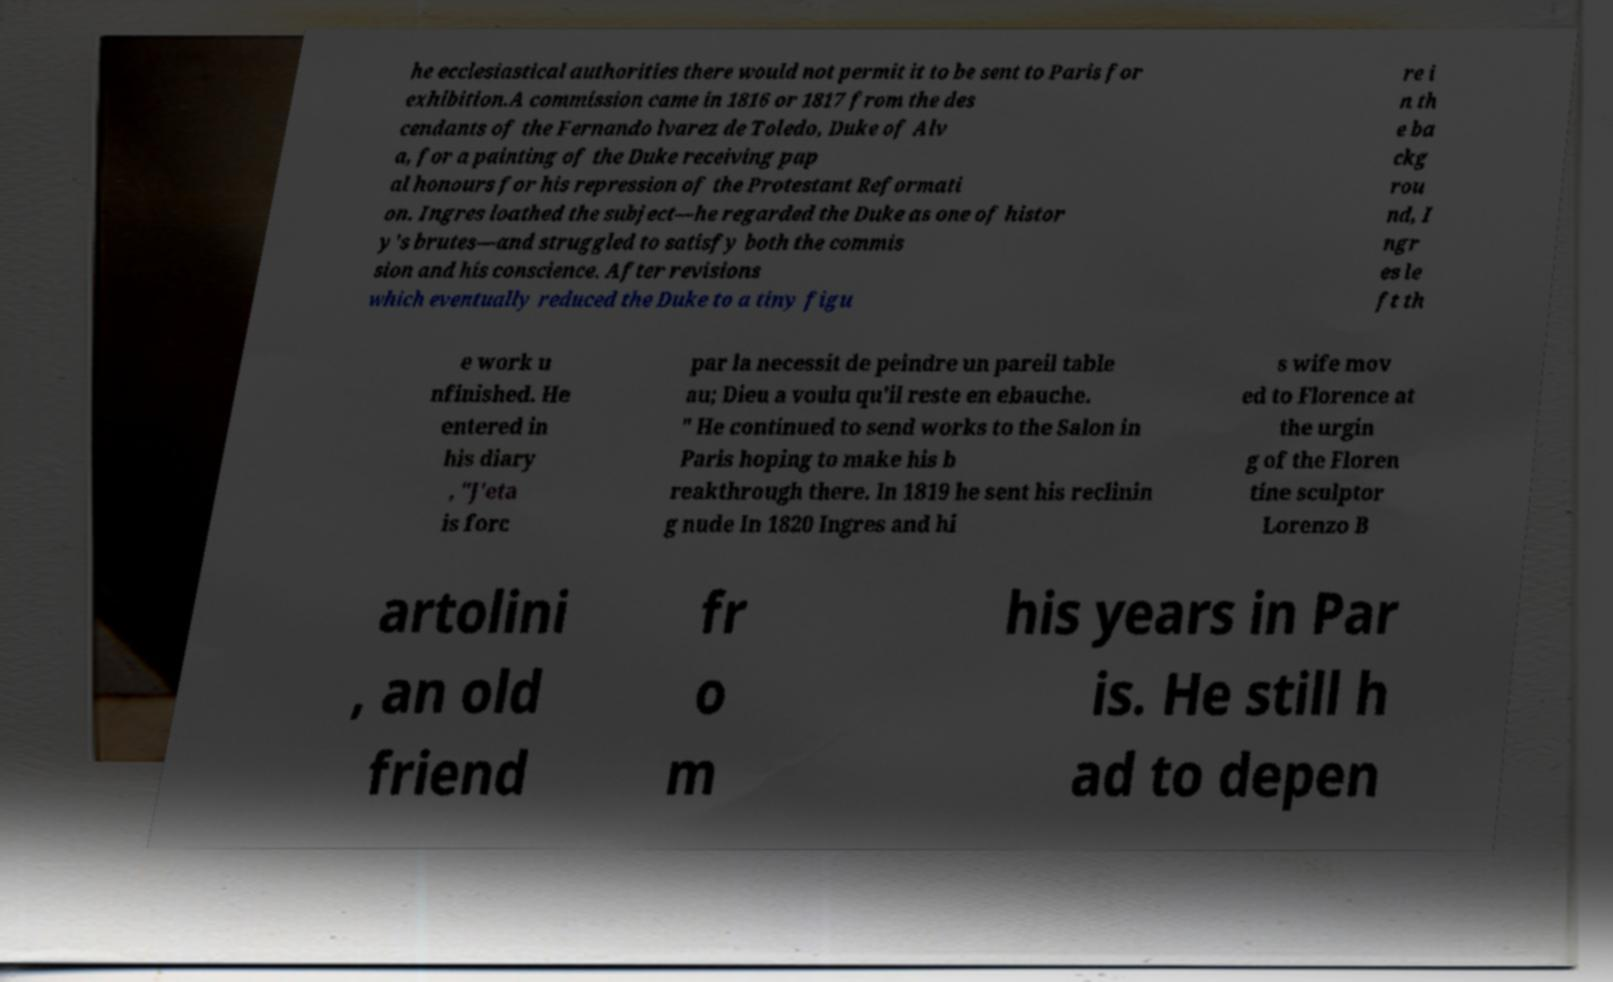Could you assist in decoding the text presented in this image and type it out clearly? he ecclesiastical authorities there would not permit it to be sent to Paris for exhibition.A commission came in 1816 or 1817 from the des cendants of the Fernando lvarez de Toledo, Duke of Alv a, for a painting of the Duke receiving pap al honours for his repression of the Protestant Reformati on. Ingres loathed the subject—he regarded the Duke as one of histor y's brutes—and struggled to satisfy both the commis sion and his conscience. After revisions which eventually reduced the Duke to a tiny figu re i n th e ba ckg rou nd, I ngr es le ft th e work u nfinished. He entered in his diary , "J'eta is forc par la necessit de peindre un pareil table au; Dieu a voulu qu'il reste en ebauche. " He continued to send works to the Salon in Paris hoping to make his b reakthrough there. In 1819 he sent his reclinin g nude In 1820 Ingres and hi s wife mov ed to Florence at the urgin g of the Floren tine sculptor Lorenzo B artolini , an old friend fr o m his years in Par is. He still h ad to depen 